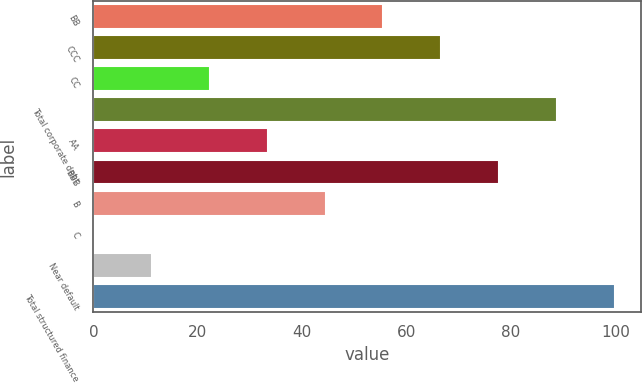Convert chart to OTSL. <chart><loc_0><loc_0><loc_500><loc_500><bar_chart><fcel>BB<fcel>CCC<fcel>CC<fcel>Total corporate debt<fcel>AA<fcel>BBB<fcel>B<fcel>C<fcel>Near default<fcel>Total structured finance<nl><fcel>55.55<fcel>66.62<fcel>22.34<fcel>88.76<fcel>33.41<fcel>77.69<fcel>44.48<fcel>0.2<fcel>11.27<fcel>99.83<nl></chart> 